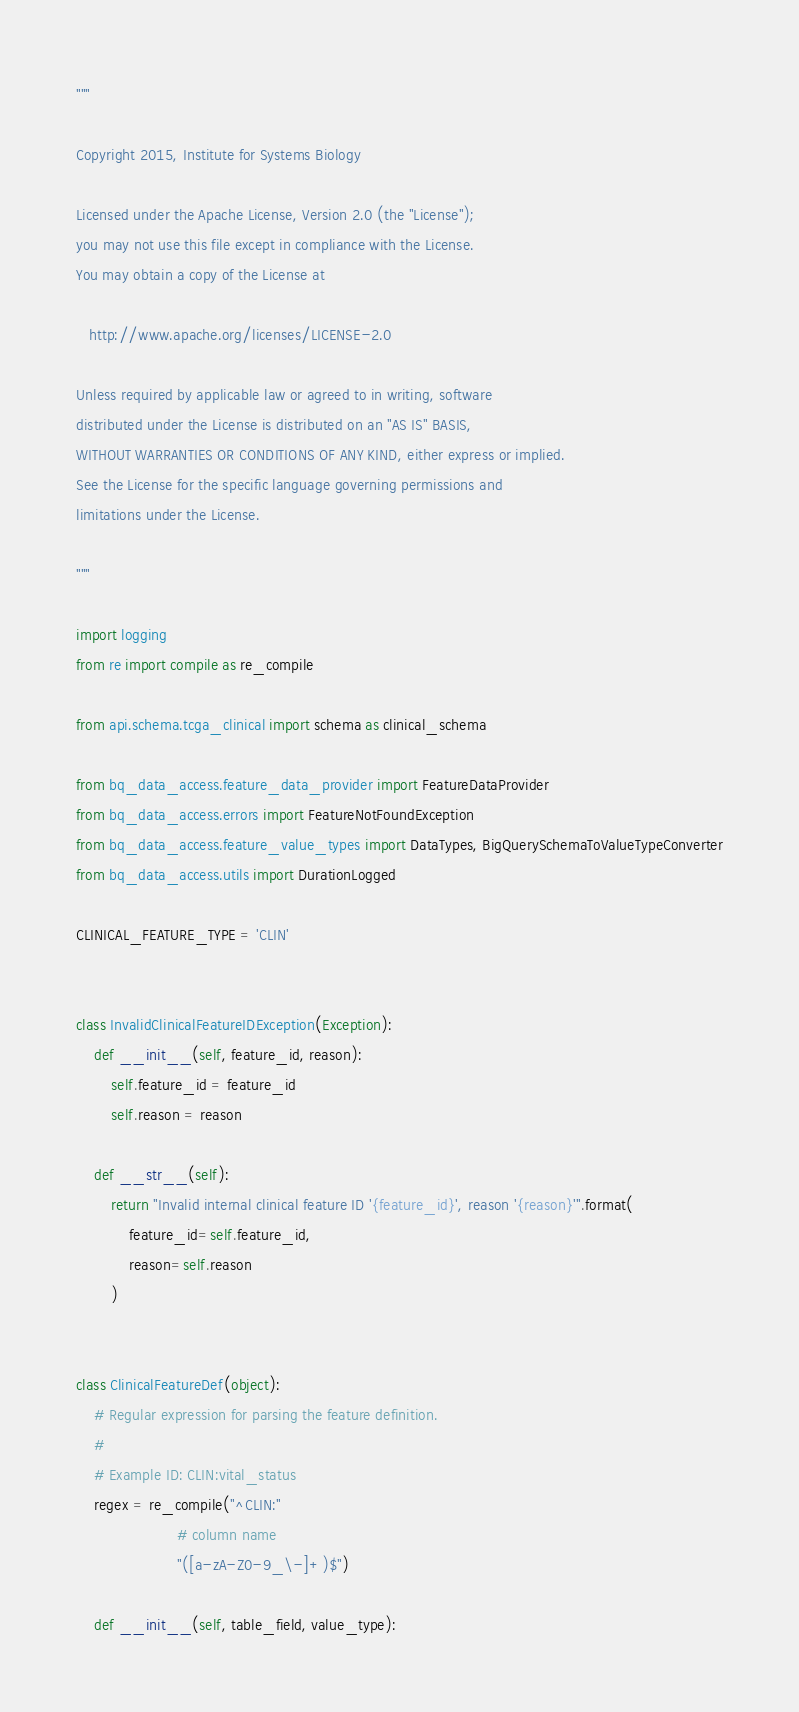Convert code to text. <code><loc_0><loc_0><loc_500><loc_500><_Python_>"""

Copyright 2015, Institute for Systems Biology

Licensed under the Apache License, Version 2.0 (the "License");
you may not use this file except in compliance with the License.
You may obtain a copy of the License at

   http://www.apache.org/licenses/LICENSE-2.0

Unless required by applicable law or agreed to in writing, software
distributed under the License is distributed on an "AS IS" BASIS,
WITHOUT WARRANTIES OR CONDITIONS OF ANY KIND, either express or implied.
See the License for the specific language governing permissions and
limitations under the License.

"""

import logging
from re import compile as re_compile

from api.schema.tcga_clinical import schema as clinical_schema

from bq_data_access.feature_data_provider import FeatureDataProvider
from bq_data_access.errors import FeatureNotFoundException
from bq_data_access.feature_value_types import DataTypes, BigQuerySchemaToValueTypeConverter
from bq_data_access.utils import DurationLogged

CLINICAL_FEATURE_TYPE = 'CLIN'


class InvalidClinicalFeatureIDException(Exception):
    def __init__(self, feature_id, reason):
        self.feature_id = feature_id
        self.reason = reason

    def __str__(self):
        return "Invalid internal clinical feature ID '{feature_id}', reason '{reason}'".format(
            feature_id=self.feature_id,
            reason=self.reason
        )


class ClinicalFeatureDef(object):
    # Regular expression for parsing the feature definition.
    #
    # Example ID: CLIN:vital_status
    regex = re_compile("^CLIN:"
                       # column name
                       "([a-zA-Z0-9_\-]+)$")

    def __init__(self, table_field, value_type):</code> 